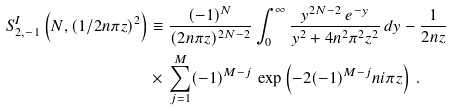Convert formula to latex. <formula><loc_0><loc_0><loc_500><loc_500>S ^ { I } _ { 2 , - 1 } \left ( N , ( 1 / 2 n \pi z ) ^ { 2 } \right ) & \equiv \frac { ( - 1 ) ^ { N } } { ( 2 n \pi z ) ^ { 2 N - 2 } } \int _ { 0 } ^ { \infty } \frac { y ^ { 2 N - 2 } \, e ^ { - y } } { y ^ { 2 } + 4 n ^ { 2 } \pi ^ { 2 } z ^ { 2 } } \, d y - \frac { 1 } { 2 n z } \\ & \times \, \sum _ { j = 1 } ^ { M } ( - 1 ) ^ { M - j } \, \exp \left ( - 2 ( - 1 ) ^ { M - j } n i \pi z \right ) \, .</formula> 